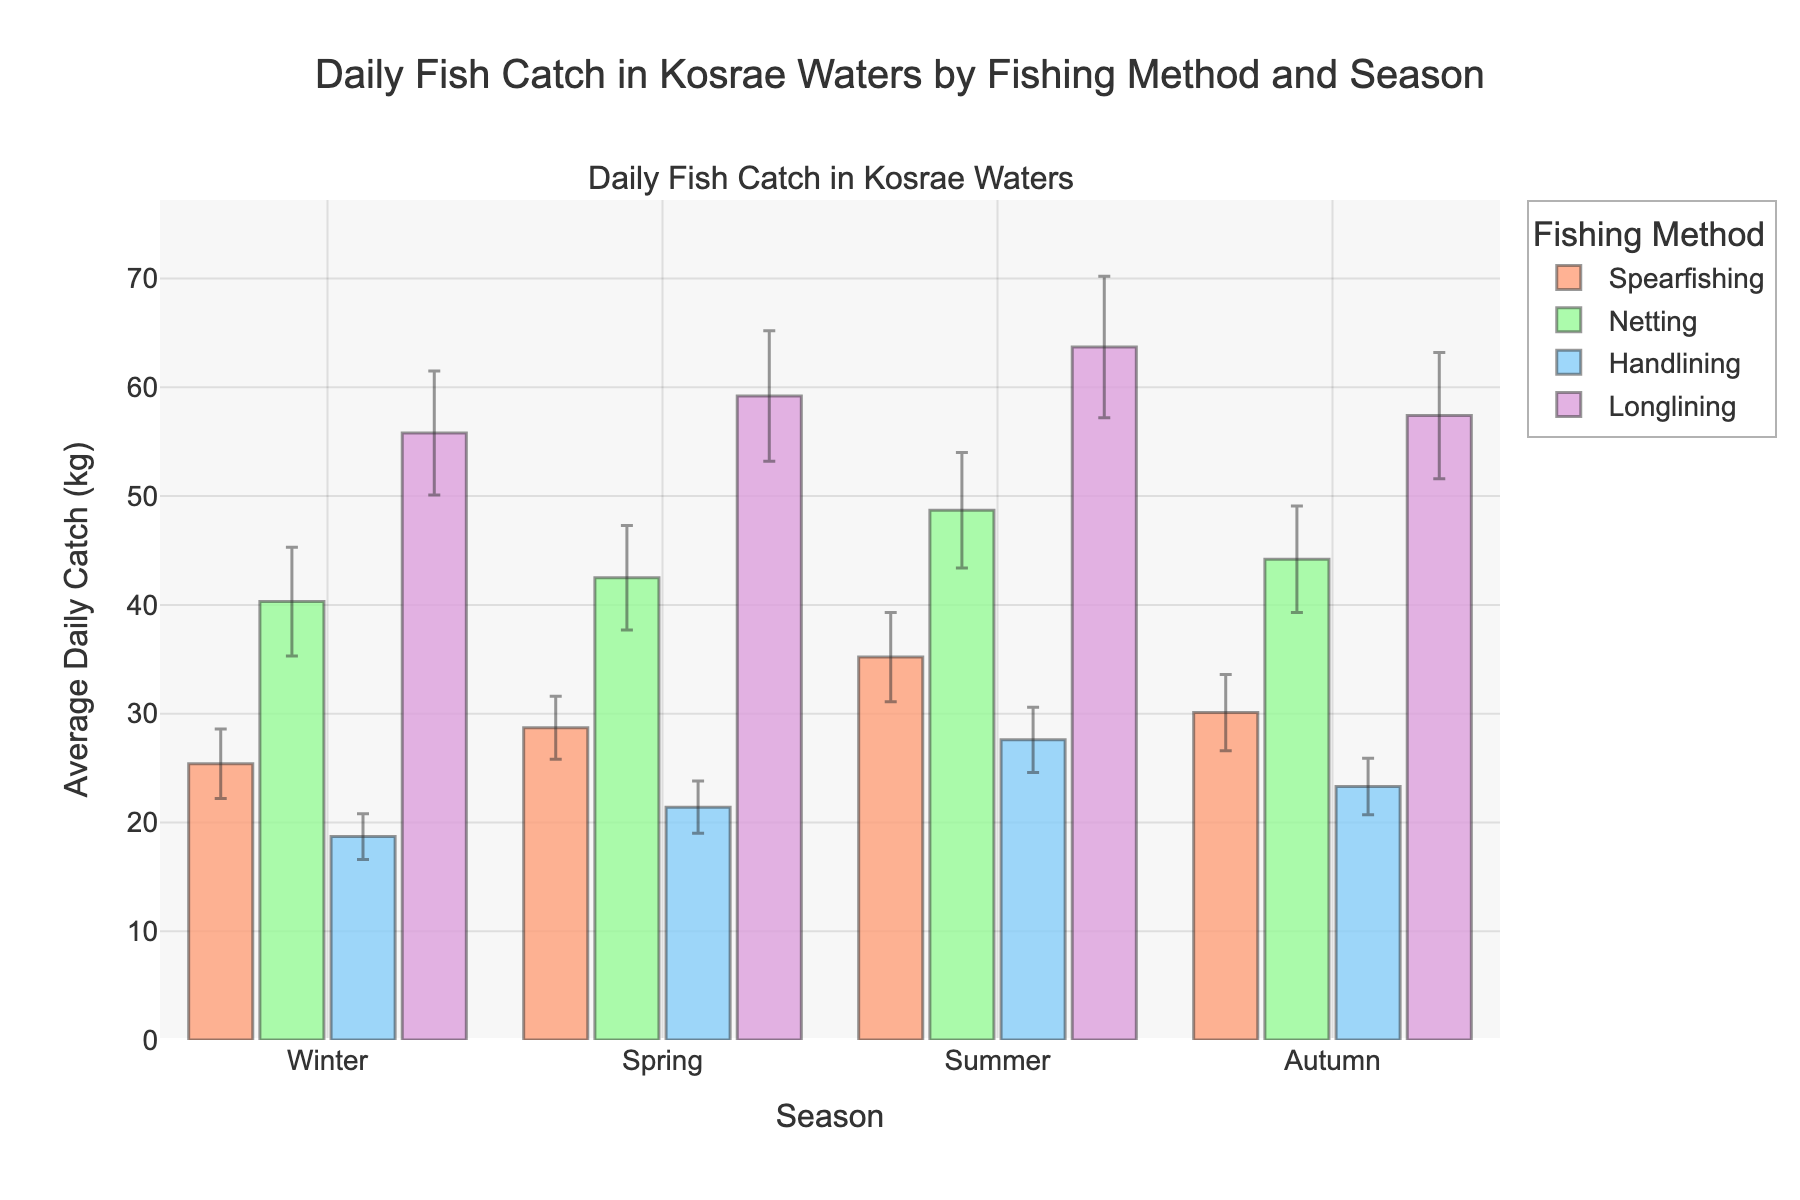What's the average daily fish catch for Spearfishing in Summer? Look at the bar corresponding to Spearfishing in the Summer season. The height of the bar gives the average daily catch.
Answer: 35.2 kg Which fishing method has the highest average daily catch in Winter? Look at the bars in the Winter season and identify the tallest one, which represents the highest average daily catch.
Answer: Longlining What is the difference between the average daily catch of Netting and Handlining in Autumn? Find the heights of the Netting and Handlining bars in Autumn. Subtract the Handlining value from the Netting value.
Answer: 20.9 kg How much does the average daily catch of Handlining change from Winter to Summer? Find the average daily catch values for Handlining in Winter and Summer. Subtract the Winter value from the Summer value.
Answer: 8.9 kg Which season has the smallest error margin for Spearfishing? Check the error margins for all seasons for Spearfishing and find the smallest one.
Answer: Spring During which season does Longlining have the smallest average daily catch? Compare the average daily catches for Longlining across all seasons and identify the smallest value.
Answer: Winter What is the total average daily catch for all fishing methods combined in Spring? Sum the average daily catches for all fishing methods in Spring.
Answer: 151.8 kg Which fishing method shows the largest variation in average daily catch across seasons? Identify the fishing method with the widest range between the highest and lowest average daily catch values across all seasons.
Answer: Longlining By how much does the average daily catch of Spearfishing in Autumn exceed the corresponding error margin? Find the average daily catch and error margin for Spearfishing in Autumn. Subtract the error margin from the average daily catch.
Answer: 26.6 kg 